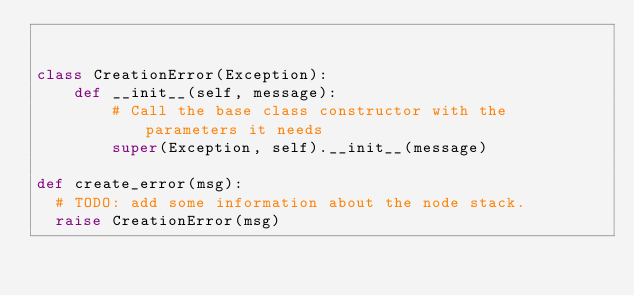Convert code to text. <code><loc_0><loc_0><loc_500><loc_500><_Python_>

class CreationError(Exception):
    def __init__(self, message):
        # Call the base class constructor with the parameters it needs
        super(Exception, self).__init__(message)

def create_error(msg):
  # TODO: add some information about the node stack.
  raise CreationError(msg)
</code> 